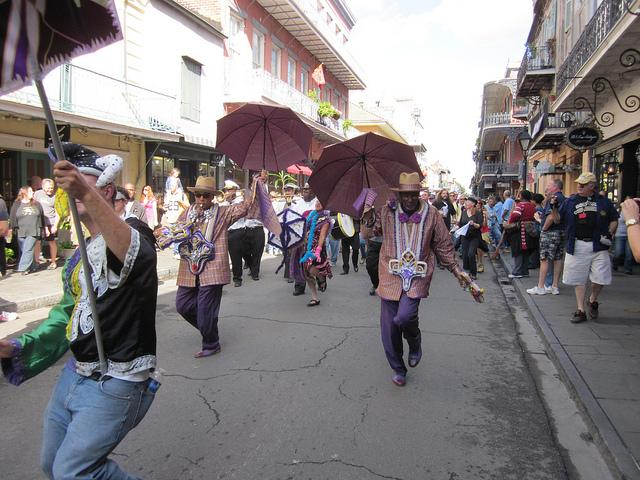What activity are people holding umbrellas taking part in? Please explain your reasoning. parade. The people are marching down the street and others are watching them. 